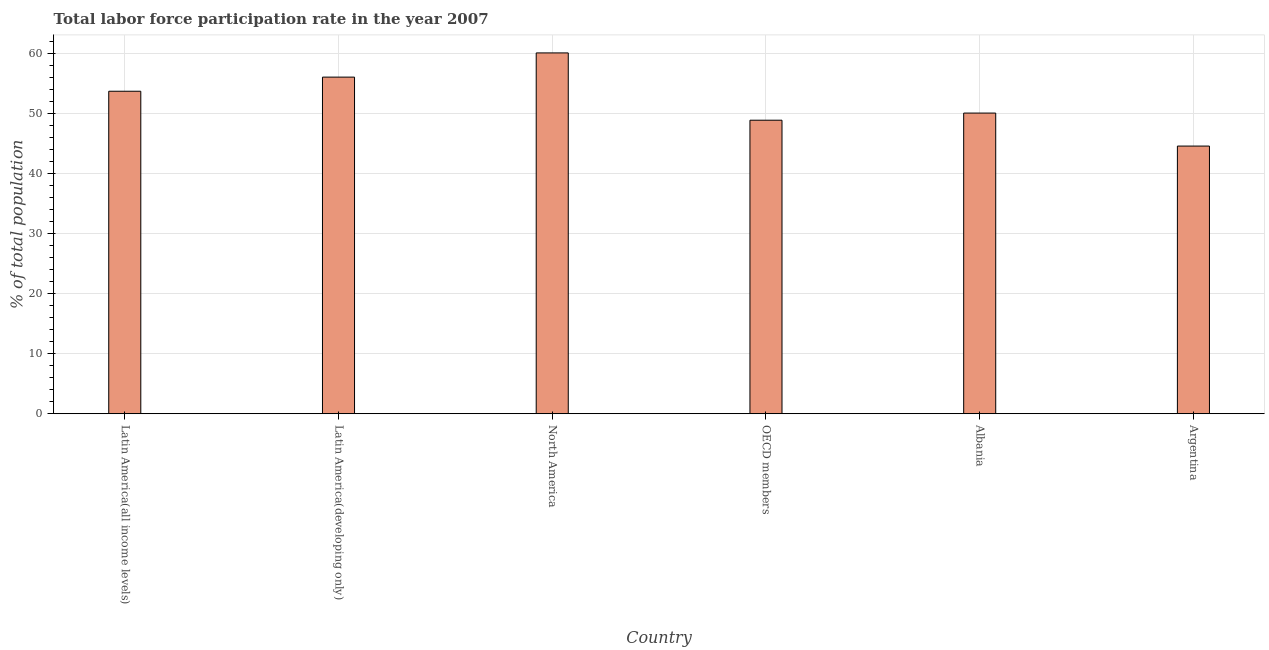What is the title of the graph?
Provide a short and direct response. Total labor force participation rate in the year 2007. What is the label or title of the Y-axis?
Your answer should be very brief. % of total population. What is the total labor force participation rate in OECD members?
Offer a terse response. 48.91. Across all countries, what is the maximum total labor force participation rate?
Provide a short and direct response. 60.12. Across all countries, what is the minimum total labor force participation rate?
Your response must be concise. 44.6. In which country was the total labor force participation rate minimum?
Provide a short and direct response. Argentina. What is the sum of the total labor force participation rate?
Your response must be concise. 313.56. What is the difference between the total labor force participation rate in Argentina and Latin America(developing only)?
Your answer should be very brief. -11.49. What is the average total labor force participation rate per country?
Your answer should be very brief. 52.26. What is the median total labor force participation rate?
Give a very brief answer. 51.92. What is the ratio of the total labor force participation rate in Argentina to that in OECD members?
Provide a short and direct response. 0.91. What is the difference between the highest and the second highest total labor force participation rate?
Give a very brief answer. 4.03. Is the sum of the total labor force participation rate in Argentina and OECD members greater than the maximum total labor force participation rate across all countries?
Ensure brevity in your answer.  Yes. What is the difference between the highest and the lowest total labor force participation rate?
Keep it short and to the point. 15.52. In how many countries, is the total labor force participation rate greater than the average total labor force participation rate taken over all countries?
Provide a short and direct response. 3. How many countries are there in the graph?
Your answer should be compact. 6. Are the values on the major ticks of Y-axis written in scientific E-notation?
Give a very brief answer. No. What is the % of total population in Latin America(all income levels)?
Give a very brief answer. 53.74. What is the % of total population of Latin America(developing only)?
Ensure brevity in your answer.  56.09. What is the % of total population of North America?
Provide a succinct answer. 60.12. What is the % of total population of OECD members?
Offer a very short reply. 48.91. What is the % of total population in Albania?
Offer a terse response. 50.1. What is the % of total population in Argentina?
Make the answer very short. 44.6. What is the difference between the % of total population in Latin America(all income levels) and Latin America(developing only)?
Provide a short and direct response. -2.35. What is the difference between the % of total population in Latin America(all income levels) and North America?
Your response must be concise. -6.39. What is the difference between the % of total population in Latin America(all income levels) and OECD members?
Your response must be concise. 4.83. What is the difference between the % of total population in Latin America(all income levels) and Albania?
Offer a terse response. 3.64. What is the difference between the % of total population in Latin America(all income levels) and Argentina?
Give a very brief answer. 9.14. What is the difference between the % of total population in Latin America(developing only) and North America?
Your answer should be compact. -4.03. What is the difference between the % of total population in Latin America(developing only) and OECD members?
Your response must be concise. 7.18. What is the difference between the % of total population in Latin America(developing only) and Albania?
Offer a very short reply. 5.99. What is the difference between the % of total population in Latin America(developing only) and Argentina?
Provide a short and direct response. 11.49. What is the difference between the % of total population in North America and OECD members?
Keep it short and to the point. 11.21. What is the difference between the % of total population in North America and Albania?
Provide a succinct answer. 10.02. What is the difference between the % of total population in North America and Argentina?
Provide a short and direct response. 15.52. What is the difference between the % of total population in OECD members and Albania?
Offer a very short reply. -1.19. What is the difference between the % of total population in OECD members and Argentina?
Make the answer very short. 4.31. What is the ratio of the % of total population in Latin America(all income levels) to that in Latin America(developing only)?
Make the answer very short. 0.96. What is the ratio of the % of total population in Latin America(all income levels) to that in North America?
Make the answer very short. 0.89. What is the ratio of the % of total population in Latin America(all income levels) to that in OECD members?
Your response must be concise. 1.1. What is the ratio of the % of total population in Latin America(all income levels) to that in Albania?
Make the answer very short. 1.07. What is the ratio of the % of total population in Latin America(all income levels) to that in Argentina?
Offer a very short reply. 1.21. What is the ratio of the % of total population in Latin America(developing only) to that in North America?
Your response must be concise. 0.93. What is the ratio of the % of total population in Latin America(developing only) to that in OECD members?
Offer a terse response. 1.15. What is the ratio of the % of total population in Latin America(developing only) to that in Albania?
Make the answer very short. 1.12. What is the ratio of the % of total population in Latin America(developing only) to that in Argentina?
Offer a very short reply. 1.26. What is the ratio of the % of total population in North America to that in OECD members?
Give a very brief answer. 1.23. What is the ratio of the % of total population in North America to that in Albania?
Offer a very short reply. 1.2. What is the ratio of the % of total population in North America to that in Argentina?
Make the answer very short. 1.35. What is the ratio of the % of total population in OECD members to that in Argentina?
Offer a very short reply. 1.1. What is the ratio of the % of total population in Albania to that in Argentina?
Your answer should be compact. 1.12. 